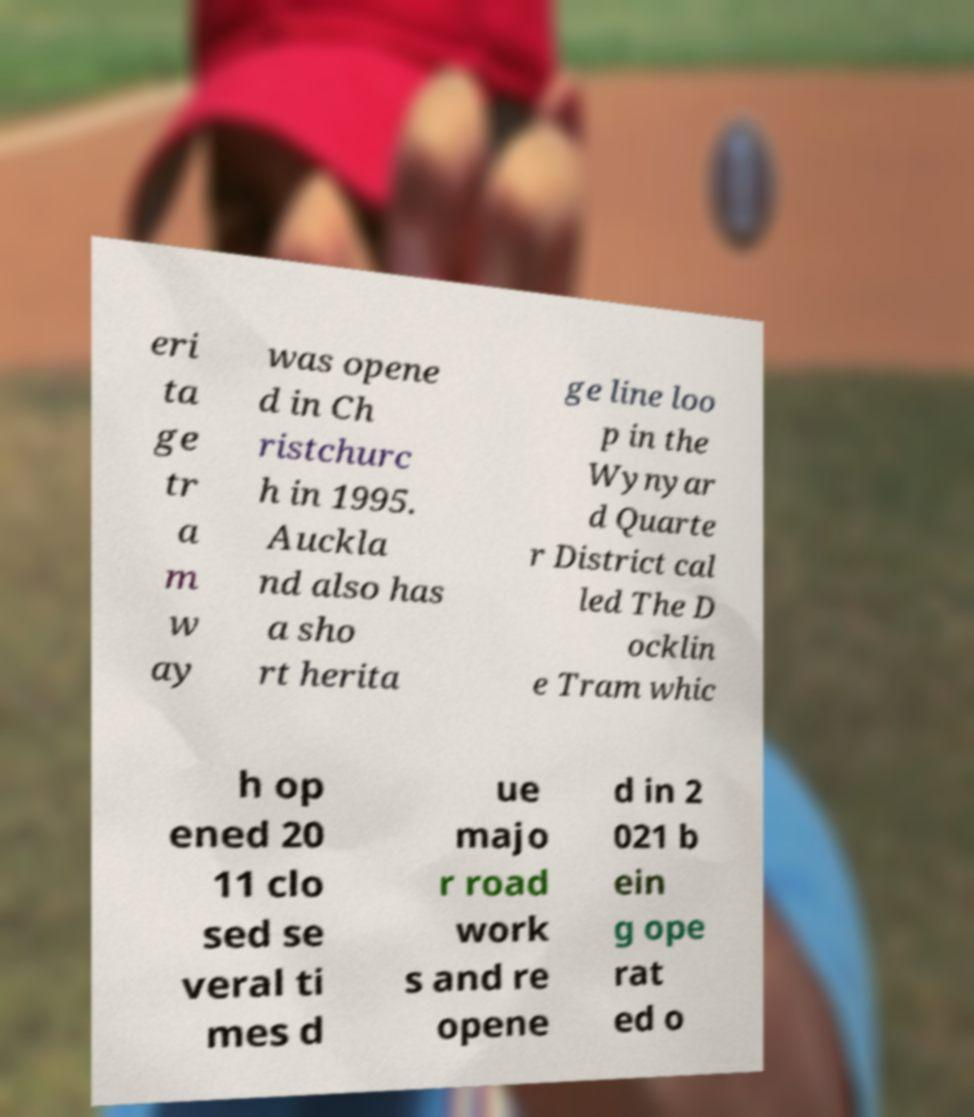Could you assist in decoding the text presented in this image and type it out clearly? eri ta ge tr a m w ay was opene d in Ch ristchurc h in 1995. Auckla nd also has a sho rt herita ge line loo p in the Wynyar d Quarte r District cal led The D ocklin e Tram whic h op ened 20 11 clo sed se veral ti mes d ue majo r road work s and re opene d in 2 021 b ein g ope rat ed o 